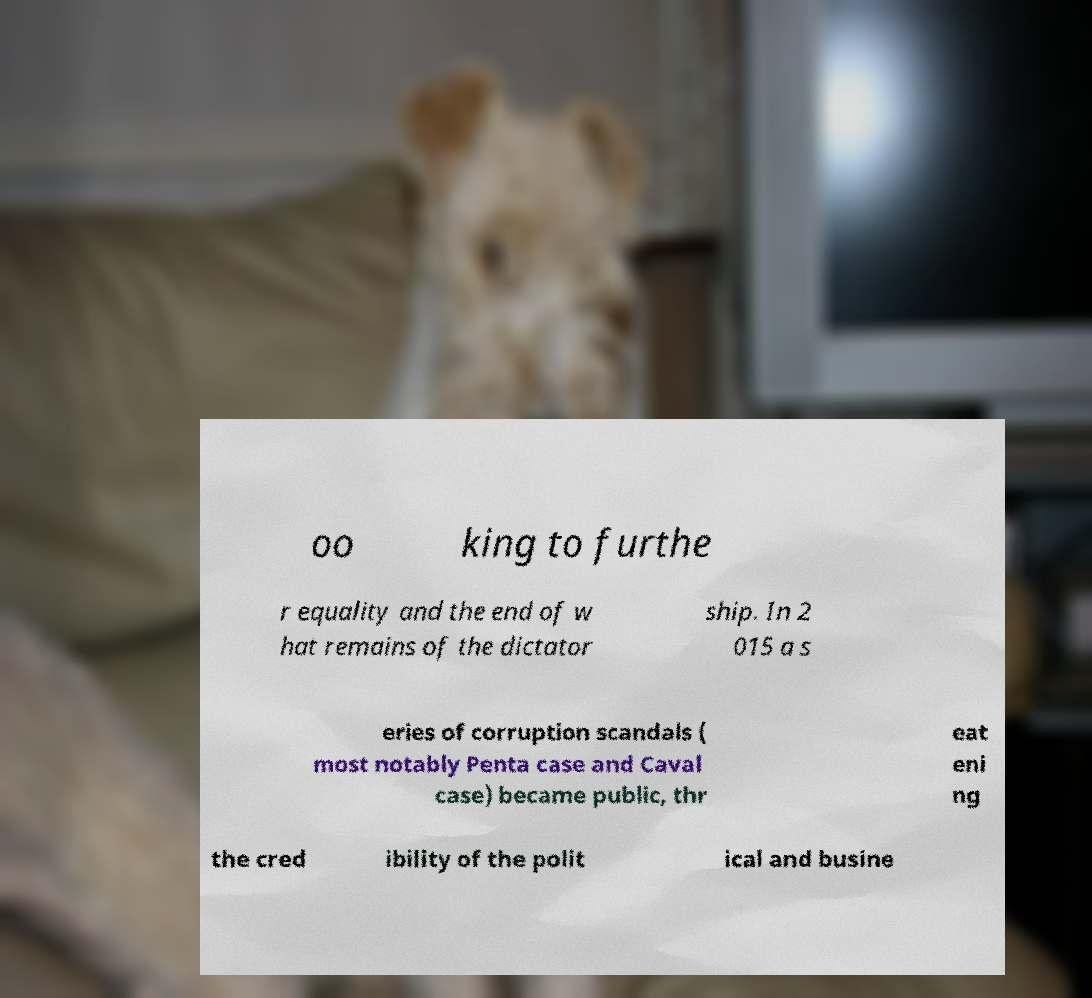Please identify and transcribe the text found in this image. oo king to furthe r equality and the end of w hat remains of the dictator ship. In 2 015 a s eries of corruption scandals ( most notably Penta case and Caval case) became public, thr eat eni ng the cred ibility of the polit ical and busine 